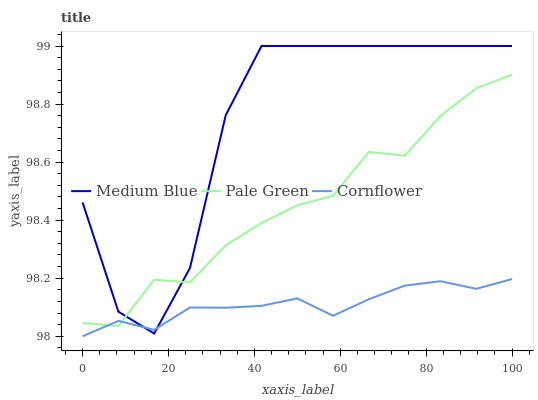Does Cornflower have the minimum area under the curve?
Answer yes or no. Yes. Does Medium Blue have the maximum area under the curve?
Answer yes or no. Yes. Does Pale Green have the minimum area under the curve?
Answer yes or no. No. Does Pale Green have the maximum area under the curve?
Answer yes or no. No. Is Cornflower the smoothest?
Answer yes or no. Yes. Is Medium Blue the roughest?
Answer yes or no. Yes. Is Pale Green the smoothest?
Answer yes or no. No. Is Pale Green the roughest?
Answer yes or no. No. Does Cornflower have the lowest value?
Answer yes or no. Yes. Does Medium Blue have the lowest value?
Answer yes or no. No. Does Medium Blue have the highest value?
Answer yes or no. Yes. Does Pale Green have the highest value?
Answer yes or no. No. Does Medium Blue intersect Pale Green?
Answer yes or no. Yes. Is Medium Blue less than Pale Green?
Answer yes or no. No. Is Medium Blue greater than Pale Green?
Answer yes or no. No. 